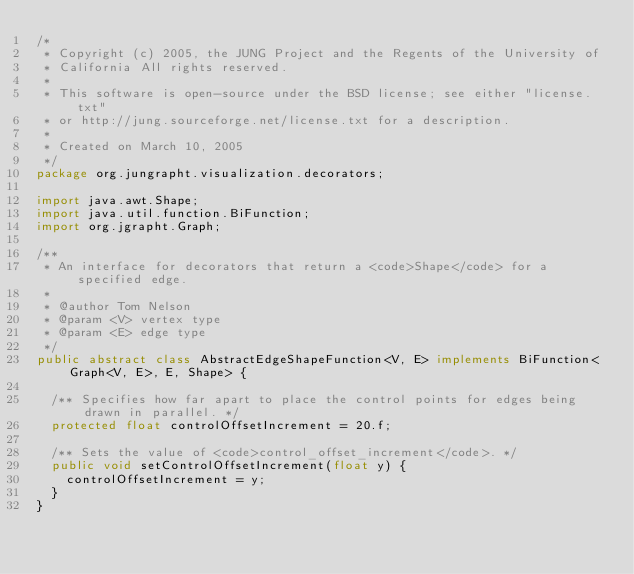Convert code to text. <code><loc_0><loc_0><loc_500><loc_500><_Java_>/*
 * Copyright (c) 2005, the JUNG Project and the Regents of the University of
 * California All rights reserved.
 *
 * This software is open-source under the BSD license; see either "license.txt"
 * or http://jung.sourceforge.net/license.txt for a description.
 *
 * Created on March 10, 2005
 */
package org.jungrapht.visualization.decorators;

import java.awt.Shape;
import java.util.function.BiFunction;
import org.jgrapht.Graph;

/**
 * An interface for decorators that return a <code>Shape</code> for a specified edge.
 *
 * @author Tom Nelson
 * @param <V> vertex type
 * @param <E> edge type
 */
public abstract class AbstractEdgeShapeFunction<V, E> implements BiFunction<Graph<V, E>, E, Shape> {

  /** Specifies how far apart to place the control points for edges being drawn in parallel. */
  protected float controlOffsetIncrement = 20.f;

  /** Sets the value of <code>control_offset_increment</code>. */
  public void setControlOffsetIncrement(float y) {
    controlOffsetIncrement = y;
  }
}
</code> 